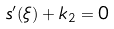Convert formula to latex. <formula><loc_0><loc_0><loc_500><loc_500>s ^ { \prime } ( \xi ) + k _ { 2 } = 0</formula> 